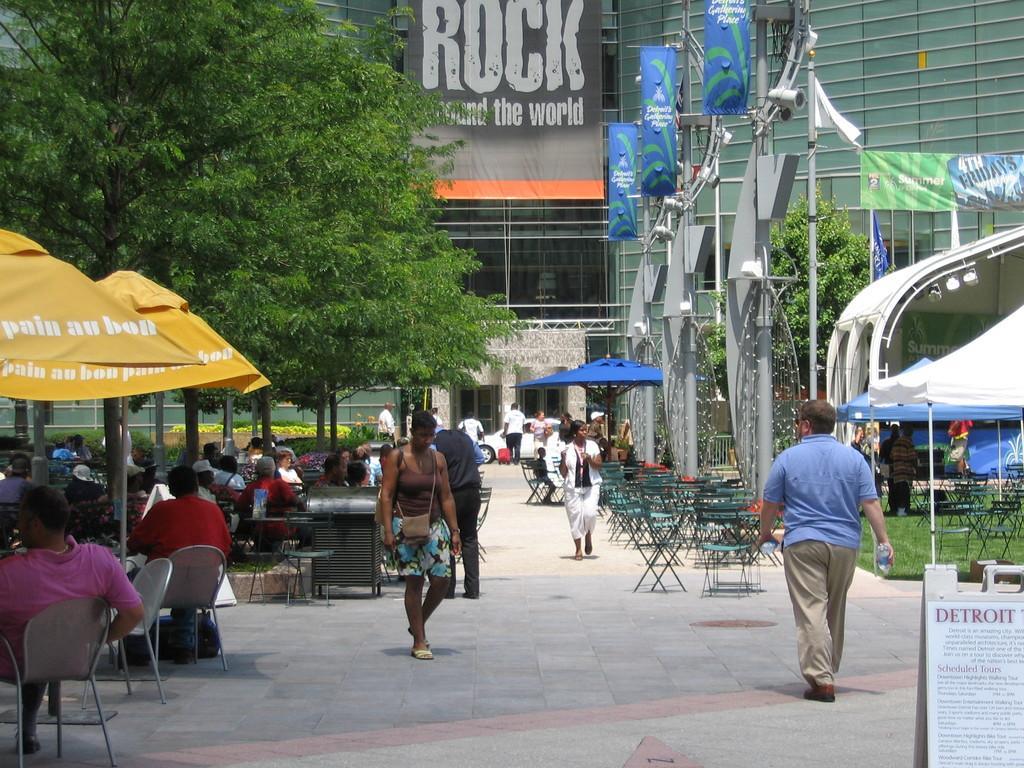How would you summarize this image in a sentence or two? In this picture, it seems to be a public place, where some people are walking while some are sitting under the umbrellas, there are some trees around the area of the image and there is a building at the right side of the image. 